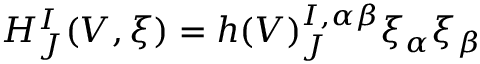Convert formula to latex. <formula><loc_0><loc_0><loc_500><loc_500>H _ { J } ^ { I } ( V , \xi ) = h ( V ) _ { J } ^ { I , \alpha \beta } \xi _ { \alpha } \xi _ { \beta }</formula> 